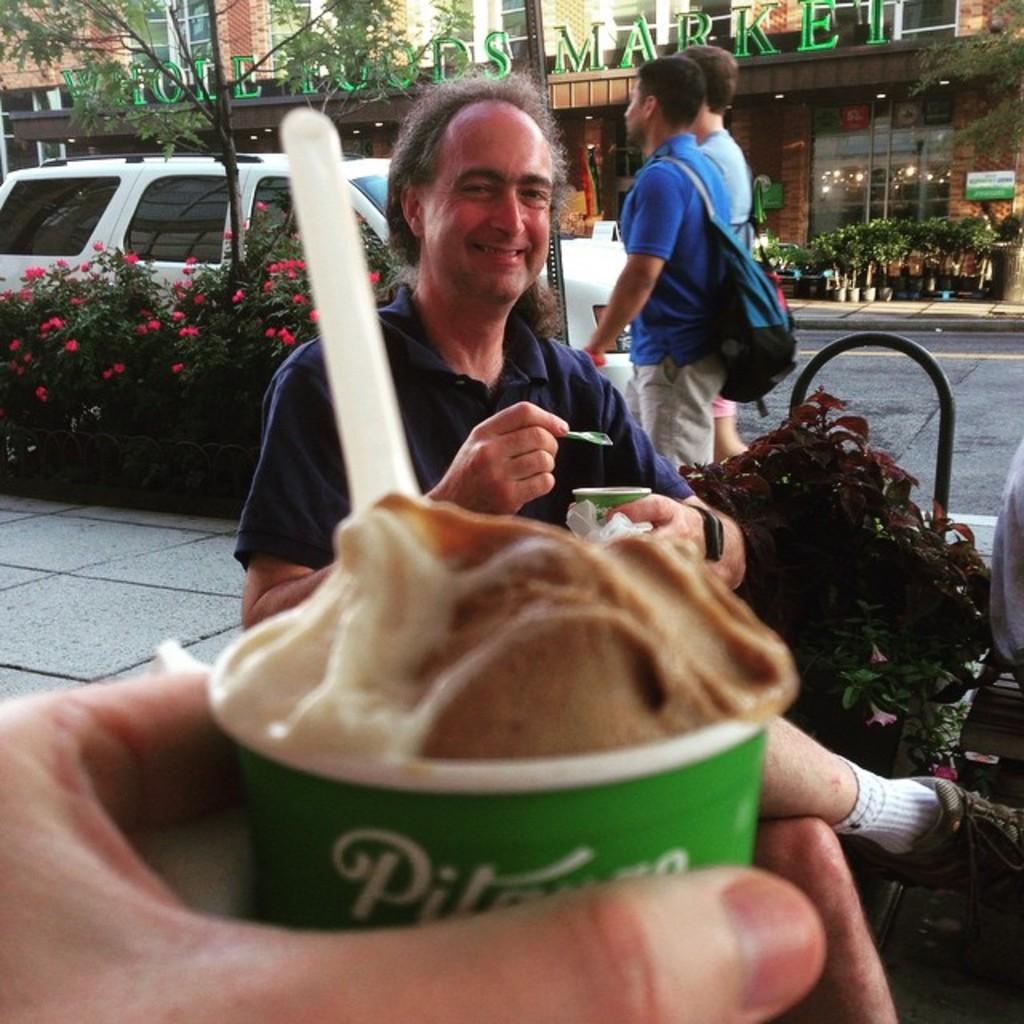Please provide a concise description of this image. As we can see in the image there are group of people, plants, flowers, bus and buildings. In the front there is a person holding cup. In cup there is an ice cream. 